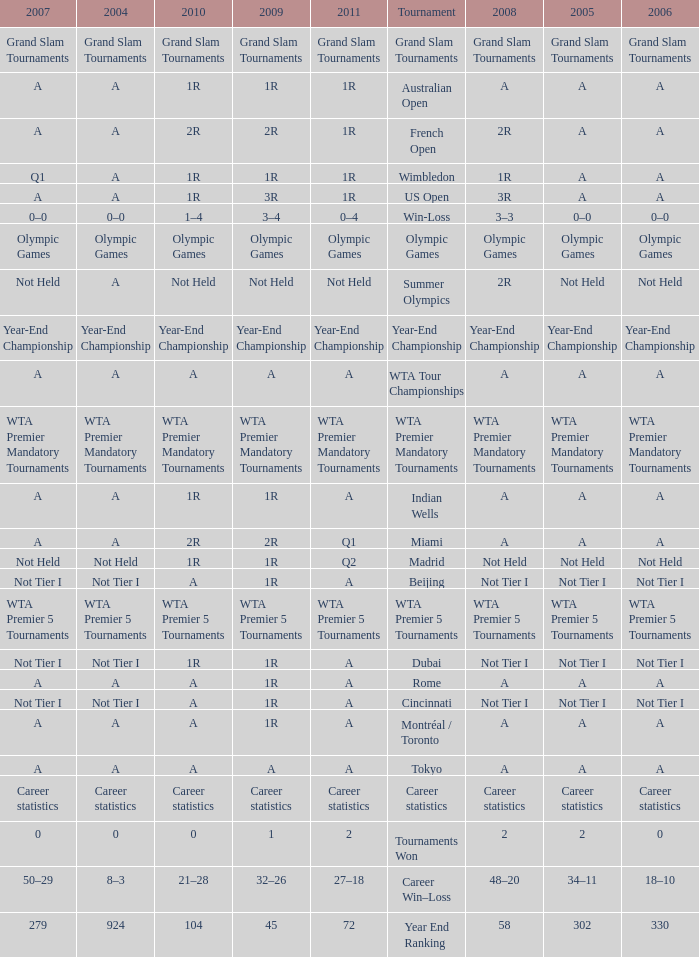What is 2010, when 2009 is "1"? 0.0. 